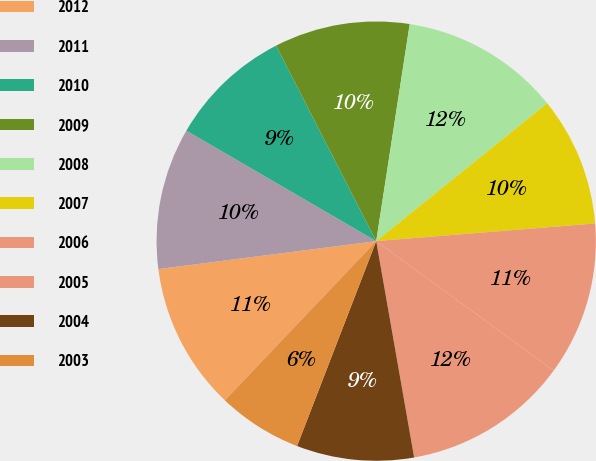Convert chart. <chart><loc_0><loc_0><loc_500><loc_500><pie_chart><fcel>2012<fcel>2011<fcel>2010<fcel>2009<fcel>2008<fcel>2007<fcel>2006<fcel>2005<fcel>2004<fcel>2003<nl><fcel>10.87%<fcel>10.42%<fcel>9.08%<fcel>9.97%<fcel>11.76%<fcel>9.52%<fcel>11.31%<fcel>12.21%<fcel>8.63%<fcel>6.23%<nl></chart> 